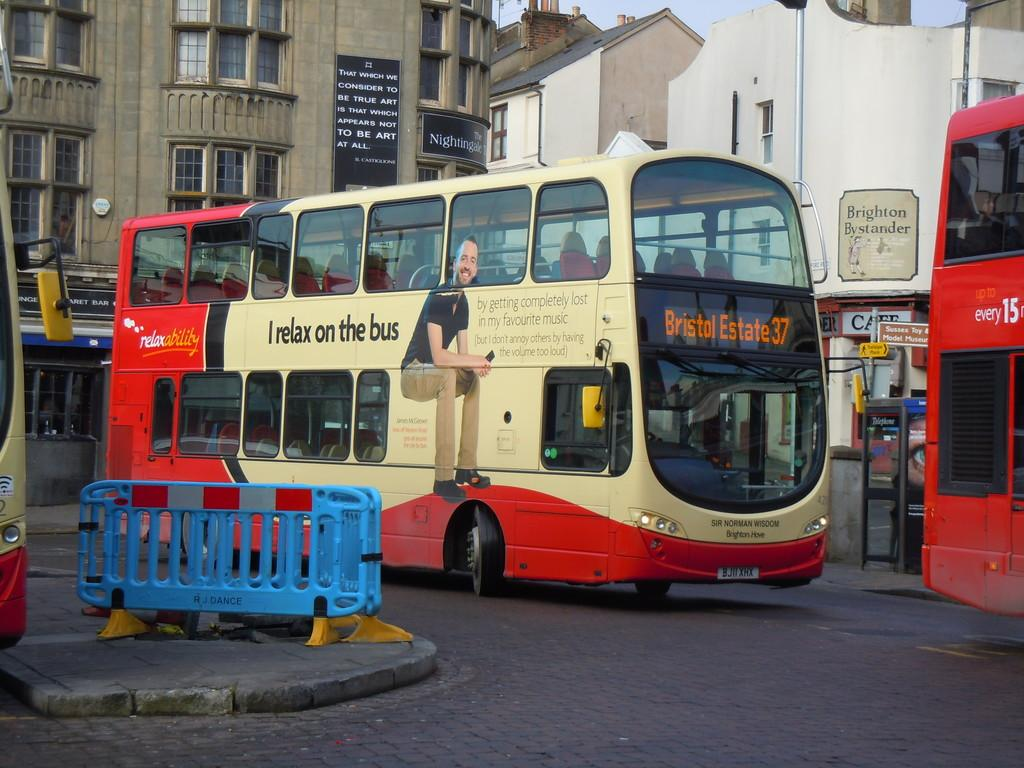What can be seen in the center of the image? There are buses on the road in the center of the image. What is located on the left side of the image? There is a fence on the left side of the image. What can be seen in the background of the image? There are buildings in the background of the image. How many dogs are sitting on the fence in the image? There are no dogs present in the image; it features buses on the road and a fence on the left side. What type of alarm is going off in the background of the image? There is no alarm present in the image; it features buses on the road, a fence on the left side, and buildings in the background. 